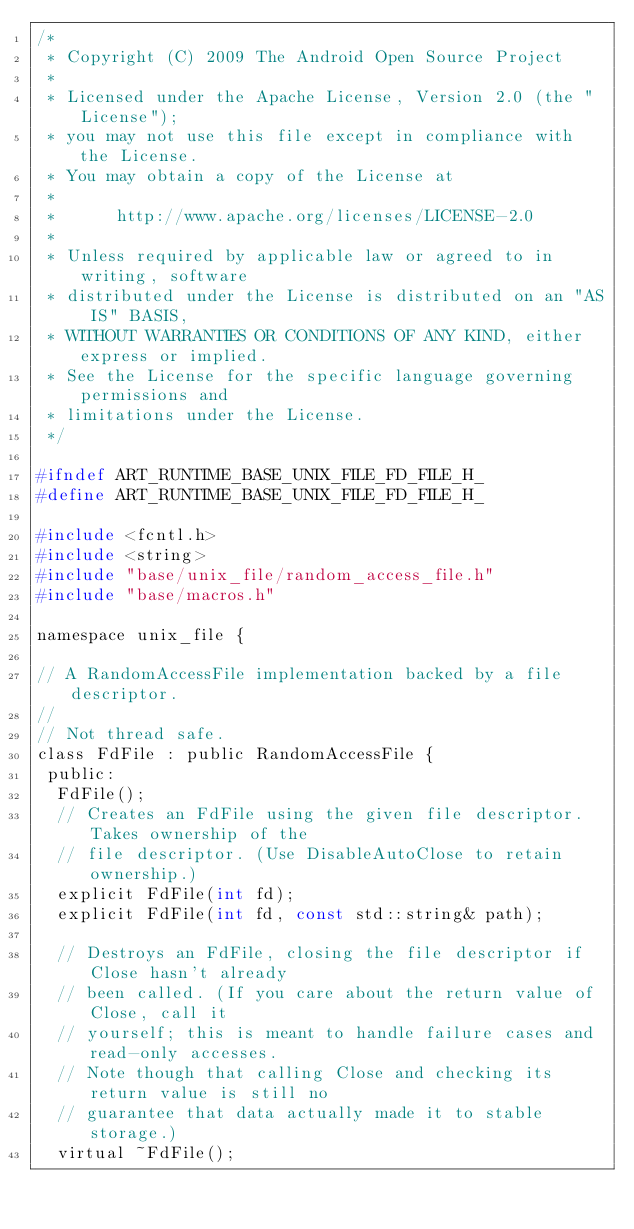<code> <loc_0><loc_0><loc_500><loc_500><_C_>/*
 * Copyright (C) 2009 The Android Open Source Project
 *
 * Licensed under the Apache License, Version 2.0 (the "License");
 * you may not use this file except in compliance with the License.
 * You may obtain a copy of the License at
 *
 *      http://www.apache.org/licenses/LICENSE-2.0
 *
 * Unless required by applicable law or agreed to in writing, software
 * distributed under the License is distributed on an "AS IS" BASIS,
 * WITHOUT WARRANTIES OR CONDITIONS OF ANY KIND, either express or implied.
 * See the License for the specific language governing permissions and
 * limitations under the License.
 */

#ifndef ART_RUNTIME_BASE_UNIX_FILE_FD_FILE_H_
#define ART_RUNTIME_BASE_UNIX_FILE_FD_FILE_H_

#include <fcntl.h>
#include <string>
#include "base/unix_file/random_access_file.h"
#include "base/macros.h"

namespace unix_file {

// A RandomAccessFile implementation backed by a file descriptor.
//
// Not thread safe.
class FdFile : public RandomAccessFile {
 public:
  FdFile();
  // Creates an FdFile using the given file descriptor. Takes ownership of the
  // file descriptor. (Use DisableAutoClose to retain ownership.)
  explicit FdFile(int fd);
  explicit FdFile(int fd, const std::string& path);

  // Destroys an FdFile, closing the file descriptor if Close hasn't already
  // been called. (If you care about the return value of Close, call it
  // yourself; this is meant to handle failure cases and read-only accesses.
  // Note though that calling Close and checking its return value is still no
  // guarantee that data actually made it to stable storage.)
  virtual ~FdFile();
</code> 